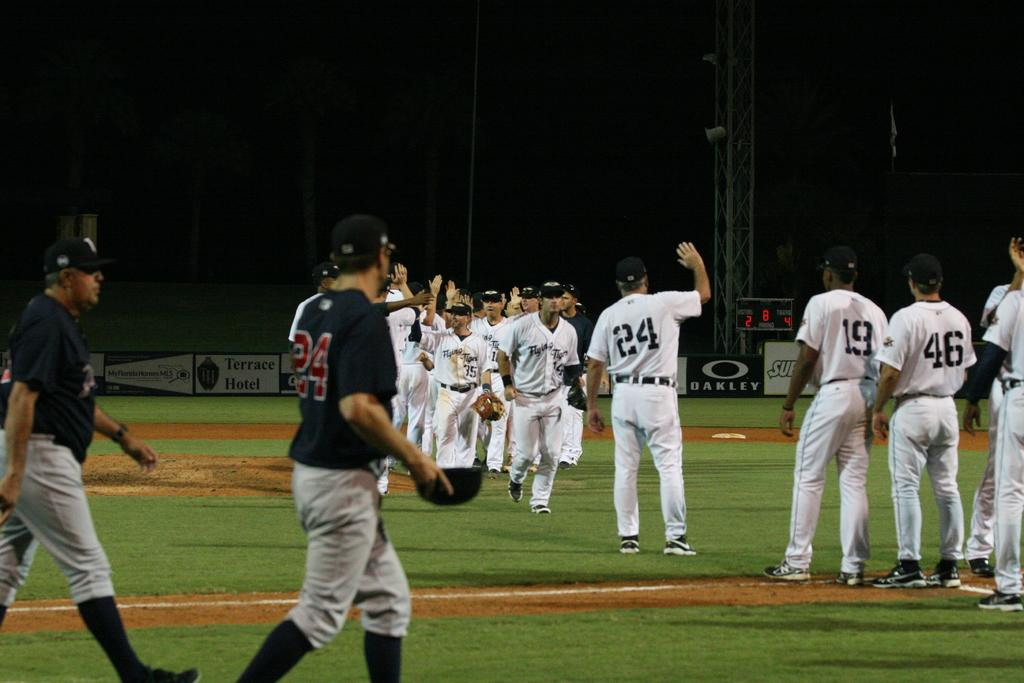Provide a one-sentence caption for the provided image. Two baseball teams are on a field with a man in a white uniform and the number 24 on his jersey getting ready to high five someone. 